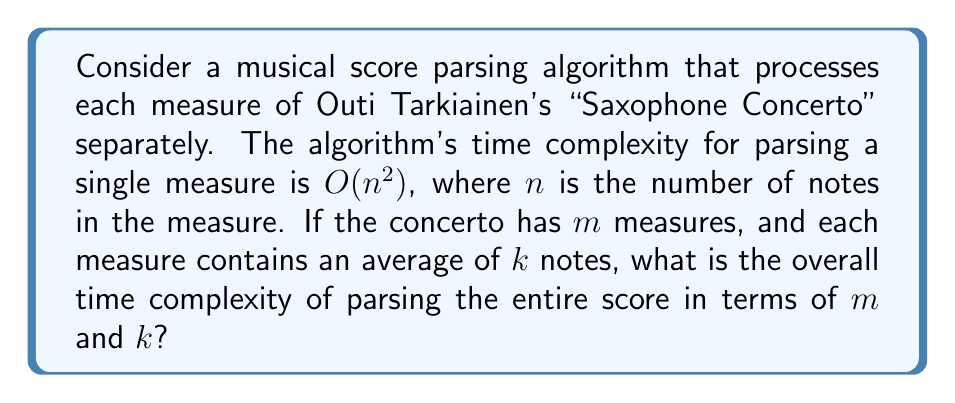Provide a solution to this math problem. Let's approach this step-by-step:

1) First, we need to understand what the question is asking. We're looking for the time complexity of parsing the entire score, given:
   - The algorithm processes each measure separately
   - The time complexity for a single measure is $O(n^2)$, where $n$ is the number of notes in that measure
   - There are $m$ measures in total
   - Each measure has an average of $k$ notes

2) Since each measure is processed separately, we can consider the total time as the sum of the time taken for each measure.

3) For a single measure with $k$ notes, the time complexity is $O(k^2)$.

4) There are $m$ measures in total, each taking $O(k^2)$ time.

5) Therefore, the total time complexity will be:

   $$O(m \cdot k^2)$$

6) This is because we're essentially performing an $O(k^2)$ operation $m$ times.

7) It's important to note that this is not $O((mk)^2)$ or $O(m^2k^2)$, as the measures are processed independently, not nested.

8) In Big O notation, we typically don't multiply by constants, so this remains our final answer.
Answer: $O(m \cdot k^2)$ 